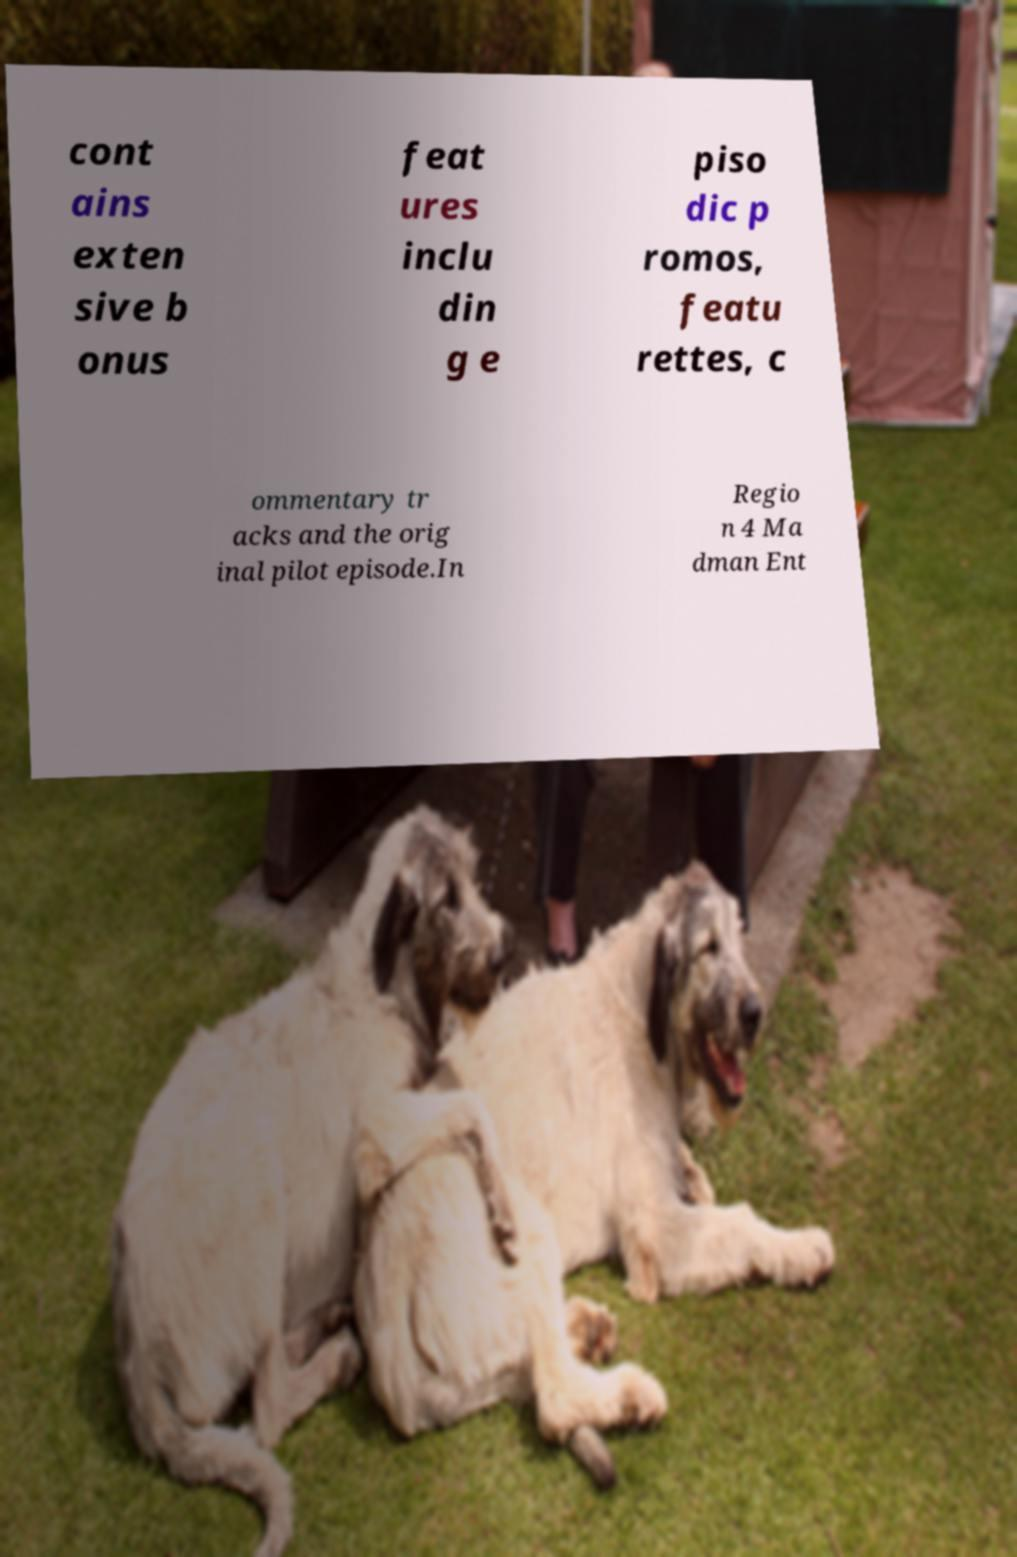What messages or text are displayed in this image? I need them in a readable, typed format. cont ains exten sive b onus feat ures inclu din g e piso dic p romos, featu rettes, c ommentary tr acks and the orig inal pilot episode.In Regio n 4 Ma dman Ent 